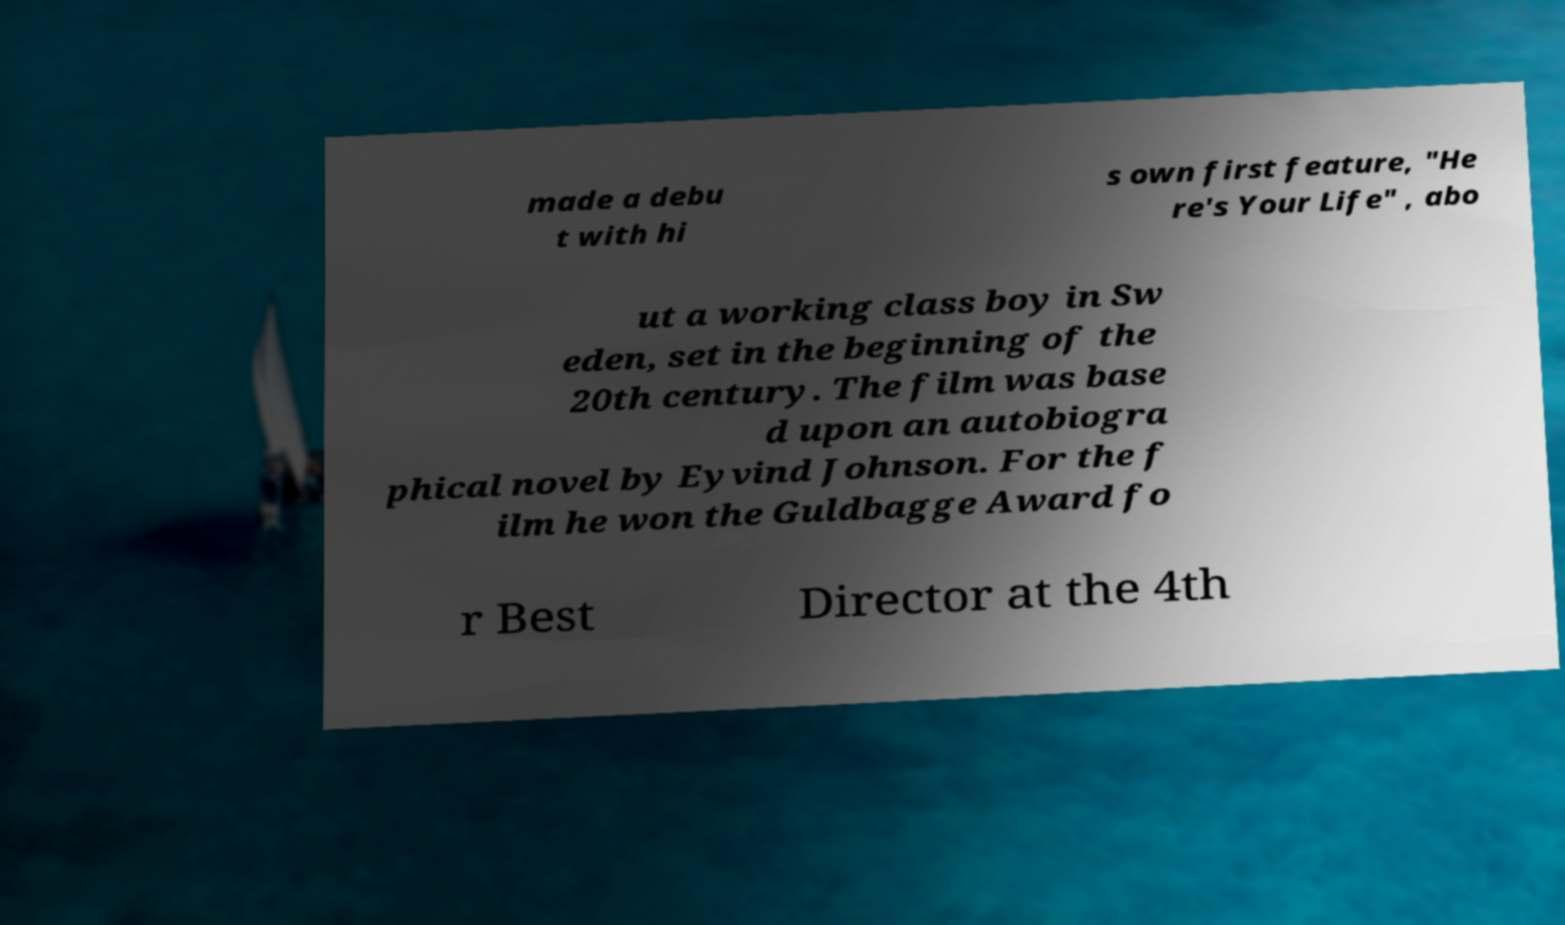Can you read and provide the text displayed in the image?This photo seems to have some interesting text. Can you extract and type it out for me? made a debu t with hi s own first feature, "He re's Your Life" , abo ut a working class boy in Sw eden, set in the beginning of the 20th century. The film was base d upon an autobiogra phical novel by Eyvind Johnson. For the f ilm he won the Guldbagge Award fo r Best Director at the 4th 